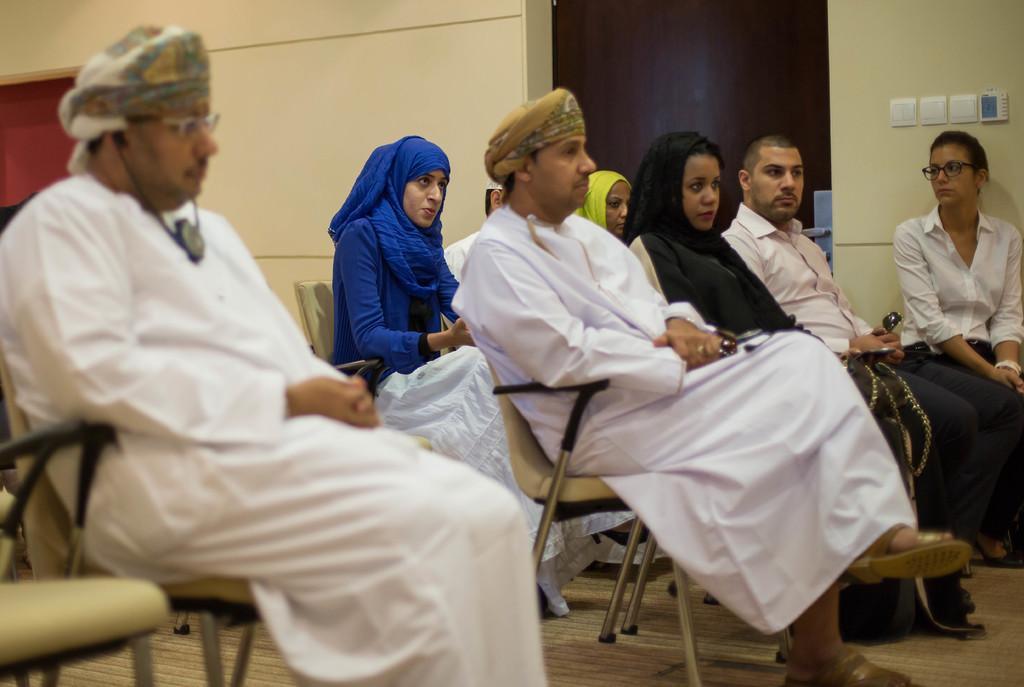Can you describe this image briefly? In this image we can see a group of people are sitting on chairs placed on the floor. One woman is wearing a blue dress. One person wearing spectacles and a cap. In the background, we can see a door and switches on the wall. 